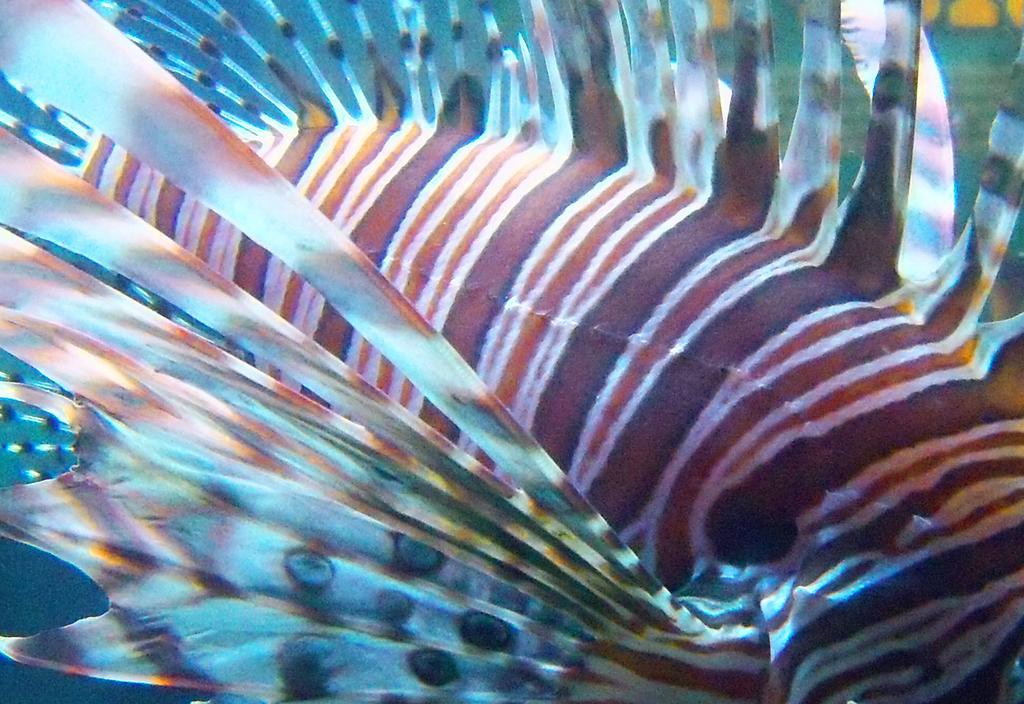What type of environment is depicted in the image? The image appears to depict an underwater environment. What type of trousers can be seen hanging on the coral reef in the image? There are no trousers present in the image, as it depicts an underwater environment. What is the cause of the fish's sore throat in the image? There is no fish with a sore throat depicted in the image, as it depicts an underwater environment. How many buckets of water are being used to clean the sea floor in the image? There are no buckets or cleaning activities depicted in the image, as it depicts an underwater environment. 